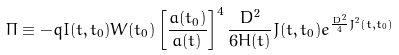<formula> <loc_0><loc_0><loc_500><loc_500>\Pi \equiv - q I ( t , t _ { 0 } ) W ( t _ { 0 } ) \left [ \frac { a ( t _ { 0 } ) } { a ( t ) } \right ] ^ { 4 } \frac { D ^ { 2 } } { 6 H ( t ) } J ( t , t _ { 0 } ) e ^ { \frac { D ^ { 2 } } { 4 } J ^ { 2 } ( t , t _ { 0 } ) }</formula> 